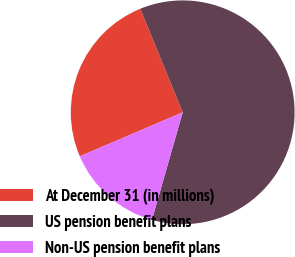Convert chart to OTSL. <chart><loc_0><loc_0><loc_500><loc_500><pie_chart><fcel>At December 31 (in millions)<fcel>US pension benefit plans<fcel>Non-US pension benefit plans<nl><fcel>25.26%<fcel>60.61%<fcel>14.13%<nl></chart> 